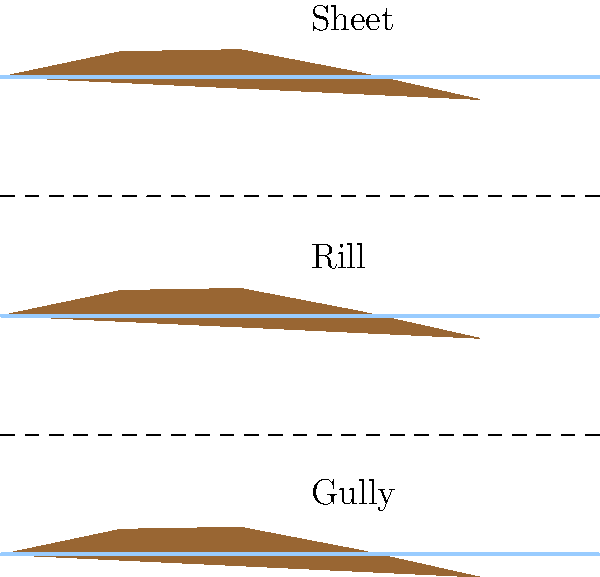Examine the illustration depicting three types of soil erosion. Which type of erosion is likely to cause the most significant and rapid soil loss, and why would this be particularly concerning for agricultural productivity? To answer this question, let's analyze each type of erosion shown in the illustration:

1. Sheet erosion (top layer):
   - Occurs uniformly over a slope
   - Removes thin layers of soil
   - Generally slower and less noticeable

2. Rill erosion (middle layer):
   - Forms small channels
   - More concentrated water flow than sheet erosion
   - Intermediate in severity

3. Gully erosion (bottom layer):
   - Creates large channels or gullies
   - Concentrates large volumes of water
   - Removes significant amounts of soil quickly

Gully erosion is the most severe because:
a) It creates deep channels that are difficult to reverse
b) It can remove large volumes of soil in a short time
c) It can rapidly expand, affecting larger areas
d) It can render land unusable for agriculture

For agricultural productivity, gully erosion is particularly concerning because:
1. It can divide fields, making them difficult to cultivate
2. It removes nutrient-rich topsoil vital for crop growth
3. It can lower the water table, reducing water availability for plants
4. It can lead to the loss of entire sections of arable land

In conclusion, gully erosion poses the greatest threat to soil conservation and agricultural productivity due to its rapid and severe impact on the landscape.
Answer: Gully erosion 